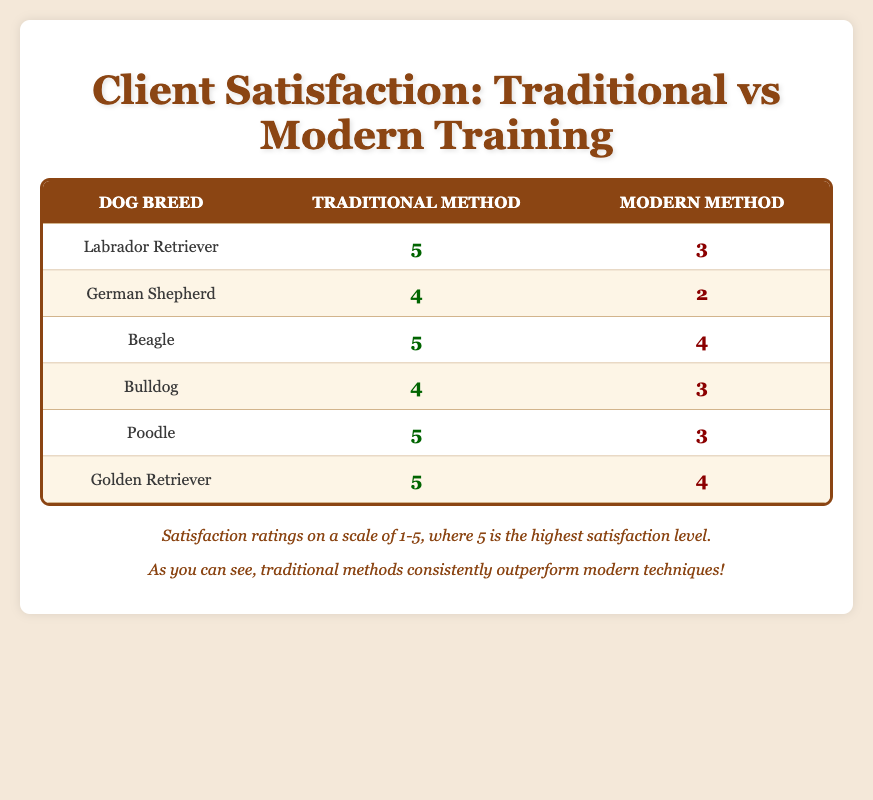What is the satisfaction rating for Labradors using traditional training methods? In the table, under the "Labrador Retriever" row and "Traditional Method" column, the satisfaction rating is 5.
Answer: 5 What is the satisfaction rating for Bulldogs using modern training methods? In the table, under the "Bulldog" row and "Modern Method" column, the satisfaction rating is 3.
Answer: 3 Which dog breed shows the highest satisfaction rating with traditional training methods? Comparing the ratings in the "Traditional Method" column, "Beagle," "Poodle," "Golden Retriever," and "Labrador Retriever" all have a rating of 5. Therefore, there are multiple breeds (Beagle, Poodle, Golden Retriever, Labrador Retriever) that tie for the highest satisfaction rating.
Answer: Beagle, Poodle, Golden Retriever, Labrador Retriever What is the average satisfaction rating for the modern training methods across all breeds? Summing the modern satisfaction ratings (3 + 2 + 4 + 3 + 3 + 4 = 19) gives a total of 19. Since there are 6 dogs, the average is 19/6, which equals approximately 3.17.
Answer: Approximately 3.17 Does any dog breed have a higher satisfaction rating for traditional training than modern training? By examining each row, "Labrador Retriever," "German Shepherd," "Beagle," "Bulldog," "Poodle," and "Golden Retriever" all have higher satisfaction ratings for the traditional training method compared to modern training. Therefore, it is true that all breeds listed have higher ratings for traditional training methods.
Answer: Yes Which dog breeds received a satisfaction rating of 5 for any training method? Checking each dog's ratings, the breeds with a score of 5 are "Labrador Retriever" (Traditional), "Beagle" (Traditional), "Poodle" (Traditional), and "Golden Retriever" (Traditional).
Answer: Labrador Retriever, Beagle, Poodle, Golden Retriever What is the difference between the highest and lowest satisfaction ratings for modern training methods? The highest rating for modern training is 4 from "Beagle" and "Golden Retriever" while the lowest rating is 2 from the "German Shepherd." Therefore, the difference is 4 - 2 = 2.
Answer: 2 Which method is consistently rated higher across all breeds? If we analyze all entries and compare traditional and modern ratings, it is clear that the traditional method consistently has higher ratings than the modern method for every breed listed. Thus, traditional methods are rated higher across all breeds.
Answer: Traditional methods 